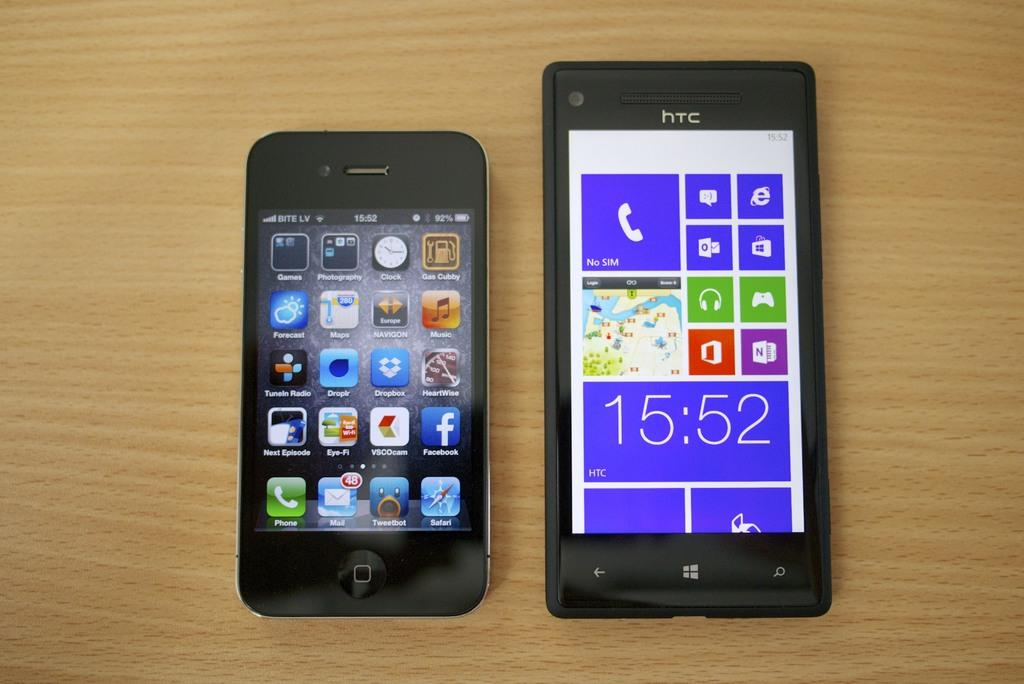Provide a one-sentence caption for the provided image. The black phone shown on the right is made by HTC. 